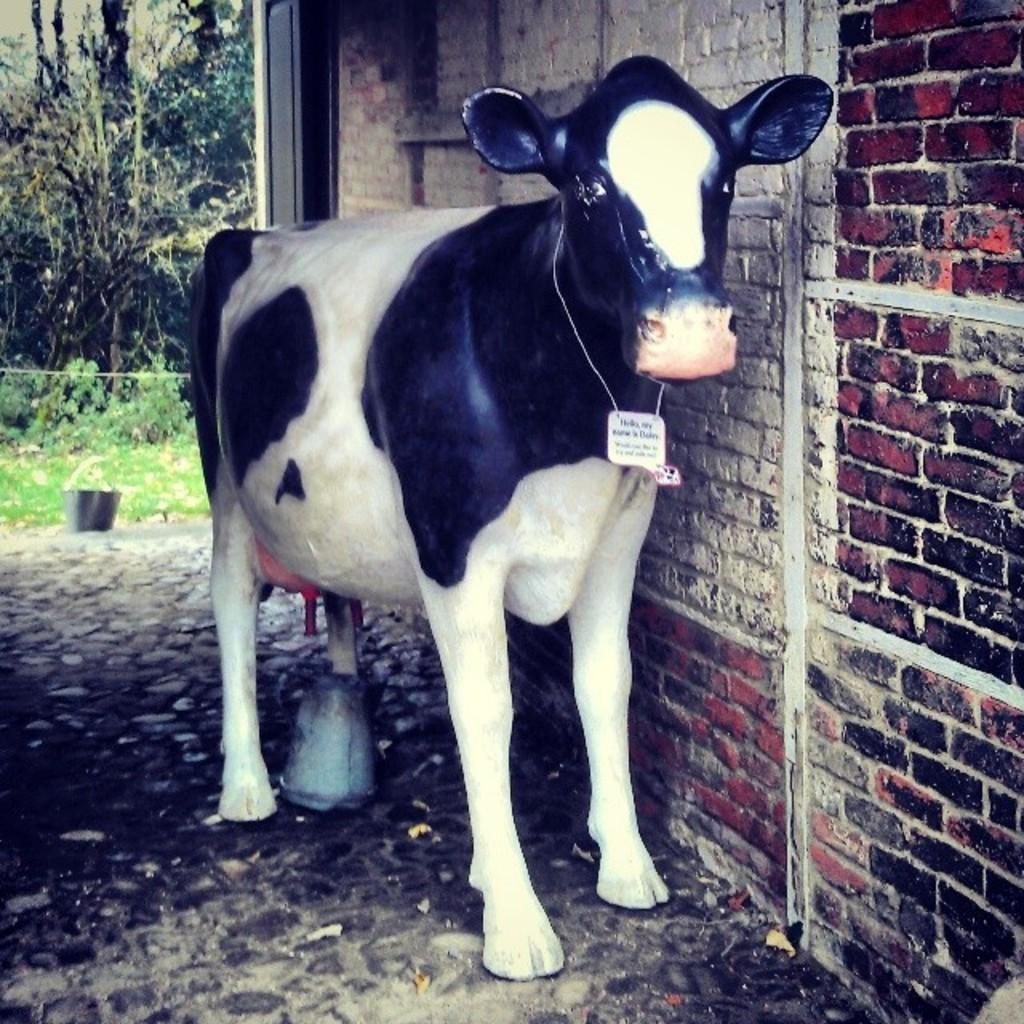What is the main subject of the image? There is a statue of a cow in the image. What can be seen in the background of the image? There is a building and trees in the background of the image. What object is present near the cow statue? There is a bucket in the image. What type of vegetation is visible at the bottom of the image? There is grass at the bottom of the image. What type of pot is visible in the image? There is no pot present in the image. How does the sleet affect the cow statue in the image? There is no sleet present in the image, so it does not affect the cow statue. 